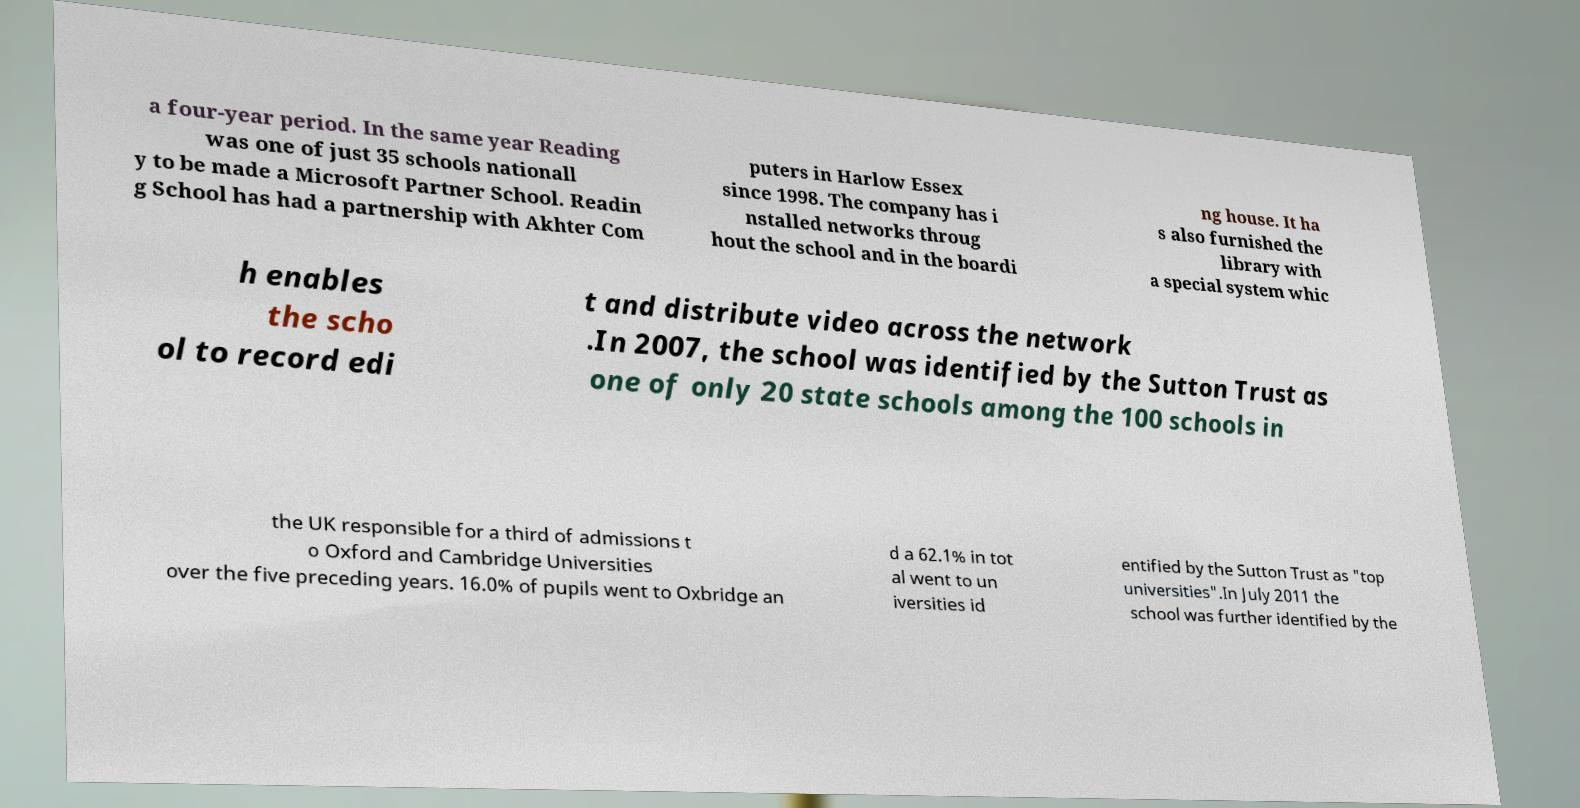Please read and relay the text visible in this image. What does it say? a four-year period. In the same year Reading was one of just 35 schools nationall y to be made a Microsoft Partner School. Readin g School has had a partnership with Akhter Com puters in Harlow Essex since 1998. The company has i nstalled networks throug hout the school and in the boardi ng house. It ha s also furnished the library with a special system whic h enables the scho ol to record edi t and distribute video across the network .In 2007, the school was identified by the Sutton Trust as one of only 20 state schools among the 100 schools in the UK responsible for a third of admissions t o Oxford and Cambridge Universities over the five preceding years. 16.0% of pupils went to Oxbridge an d a 62.1% in tot al went to un iversities id entified by the Sutton Trust as "top universities".In July 2011 the school was further identified by the 